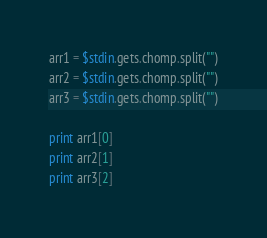<code> <loc_0><loc_0><loc_500><loc_500><_Ruby_>arr1 = $stdin.gets.chomp.split("")
arr2 = $stdin.gets.chomp.split("")
arr3 = $stdin.gets.chomp.split("")

print arr1[0]
print arr2[1]
print arr3[2]</code> 